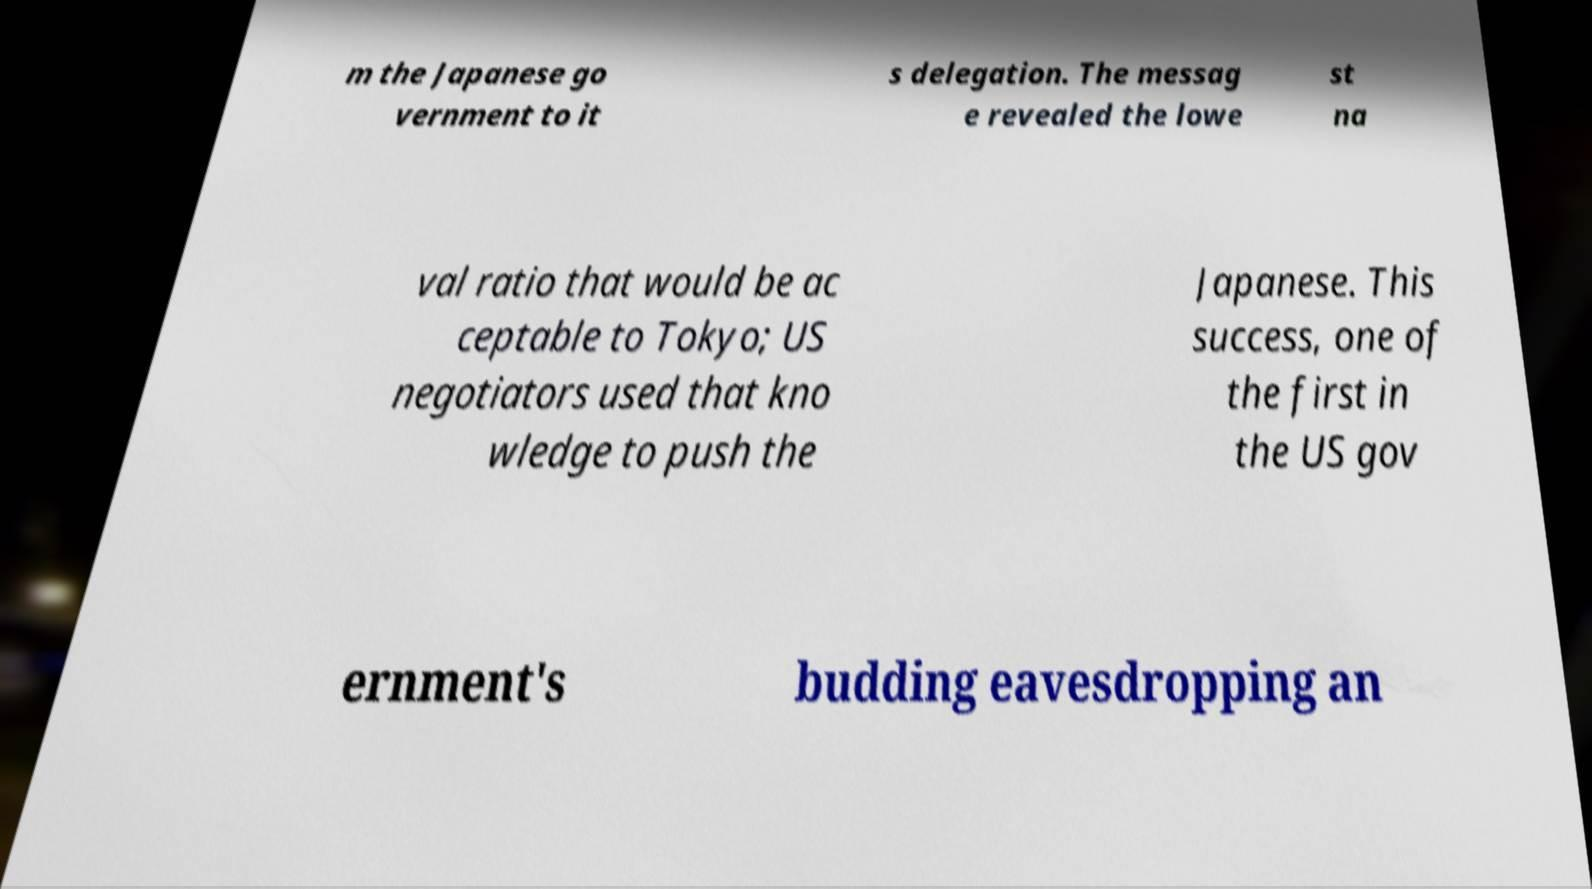What messages or text are displayed in this image? I need them in a readable, typed format. m the Japanese go vernment to it s delegation. The messag e revealed the lowe st na val ratio that would be ac ceptable to Tokyo; US negotiators used that kno wledge to push the Japanese. This success, one of the first in the US gov ernment's budding eavesdropping an 